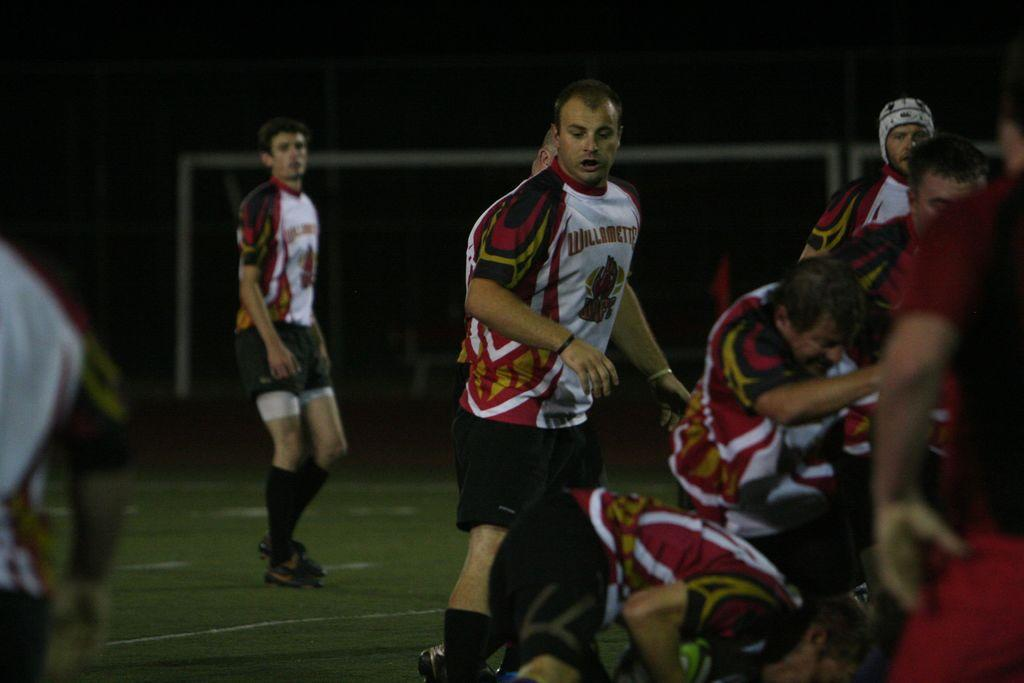Provide a one-sentence caption for the provided image. Teammates stand on a field in Willamette jerseys. 